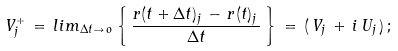<formula> <loc_0><loc_0><loc_500><loc_500>V _ { j } ^ { + } \, = \, l i m _ { \Delta t \to \, o } \left \{ \, \frac { r ( t + \Delta t ) _ { j } \, - \, r ( t ) _ { j } \, } { \Delta t } \, \right \} \, = \, ( \, V _ { j } \, + \, i \, U _ { j } \, ) \, ;</formula> 